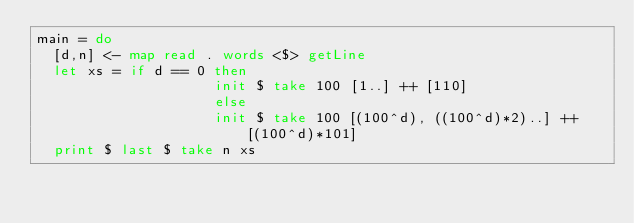<code> <loc_0><loc_0><loc_500><loc_500><_Haskell_>main = do
  [d,n] <- map read . words <$> getLine
  let xs = if d == 0 then 
                     init $ take 100 [1..] ++ [110]
                     else 
                     init $ take 100 [(100^d), ((100^d)*2)..] ++ [(100^d)*101]
  print $ last $ take n xs
</code> 